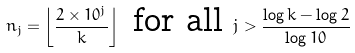<formula> <loc_0><loc_0><loc_500><loc_500>n _ { j } = \left \lfloor \frac { 2 \times 1 0 ^ { j } } { k } \right \rfloor \text { for all } j > \frac { \log { k } - \log { 2 } } { \log { 1 0 } }</formula> 